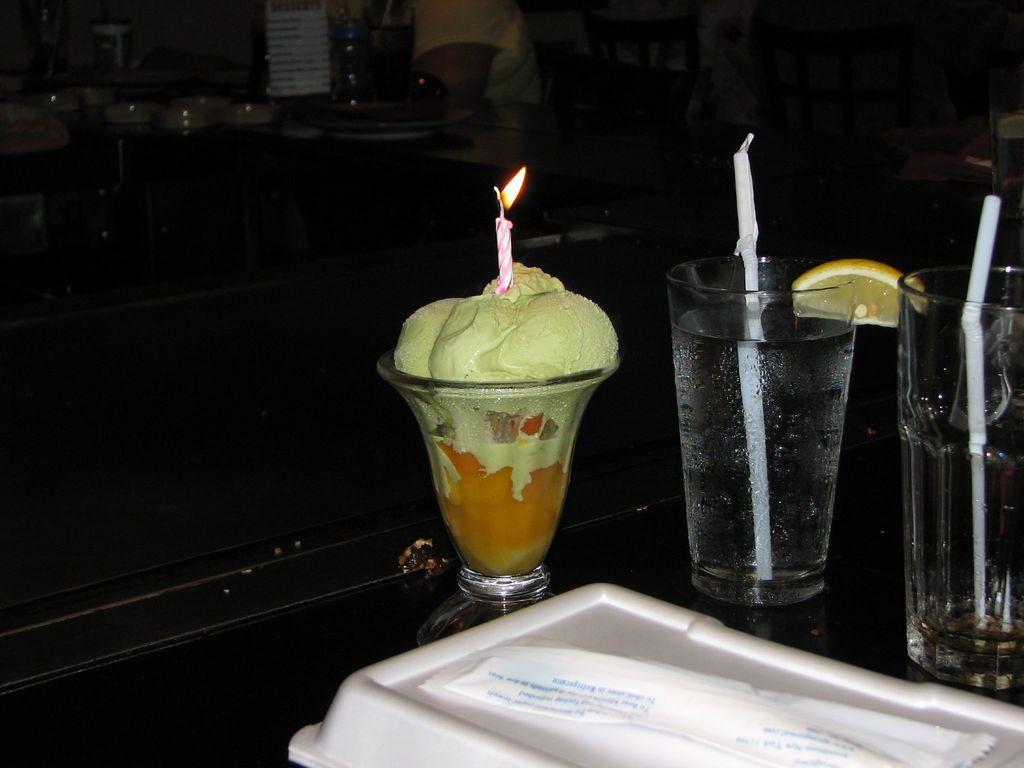How would you summarize this image in a sentence or two? In this image I can see three glasses, a candle, two straws and in the one glass I can see food. On the bottom side of this image I can see two white colour things. On the top side of this image I can see one person and I can also see this image is little bit in dark. 